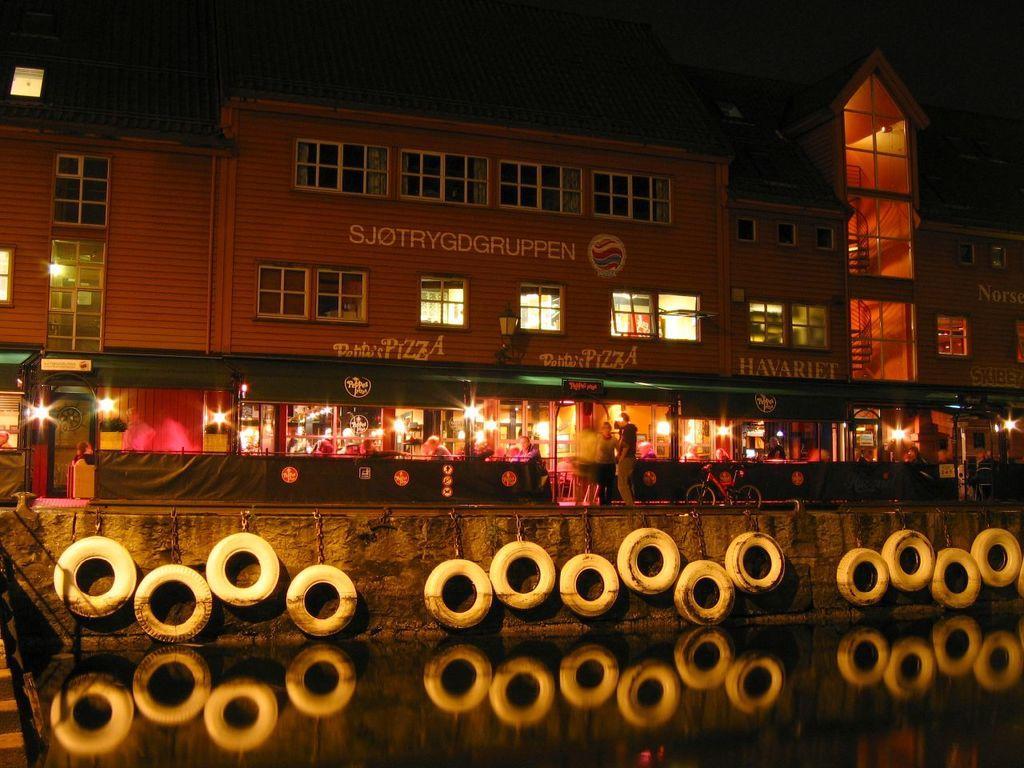Can you describe this image briefly? In this image we can see a building with windows. We can also see some people on the pathway and a bicycle parked aside. On the bottom of the image we can see some water and the tires which are changed with the chains. 